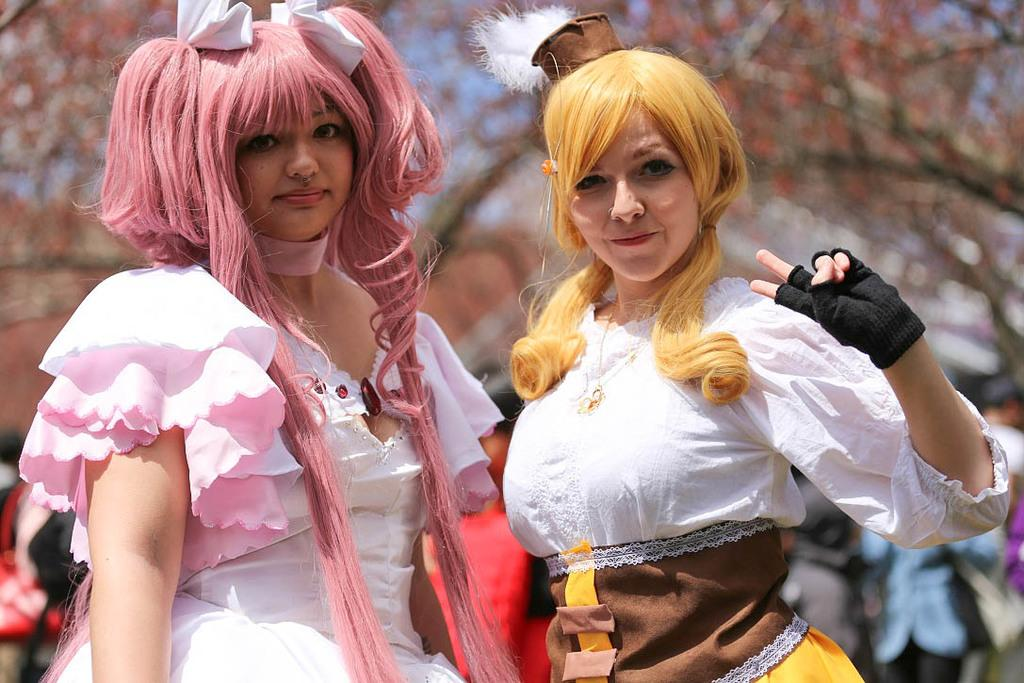How many women are in the image? There are two women standing in the image. What can be seen in the background of the image? There are people and plants visible in the background of the image. How would you describe the background of the image? The background of the image is blurry. What type of insurance policy do the women have in the image? There is no information about insurance policies in the image, as it only shows two women standing and a blurry background with people and plants. 